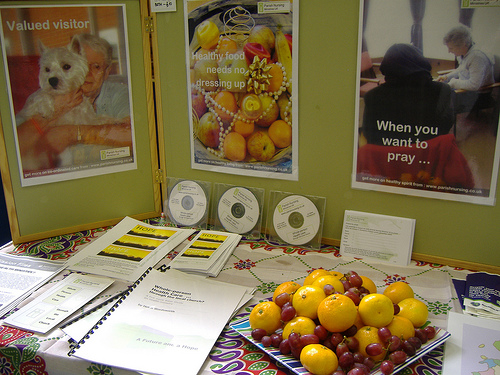<image>
Can you confirm if the fruit is on the table? Yes. Looking at the image, I can see the fruit is positioned on top of the table, with the table providing support. 